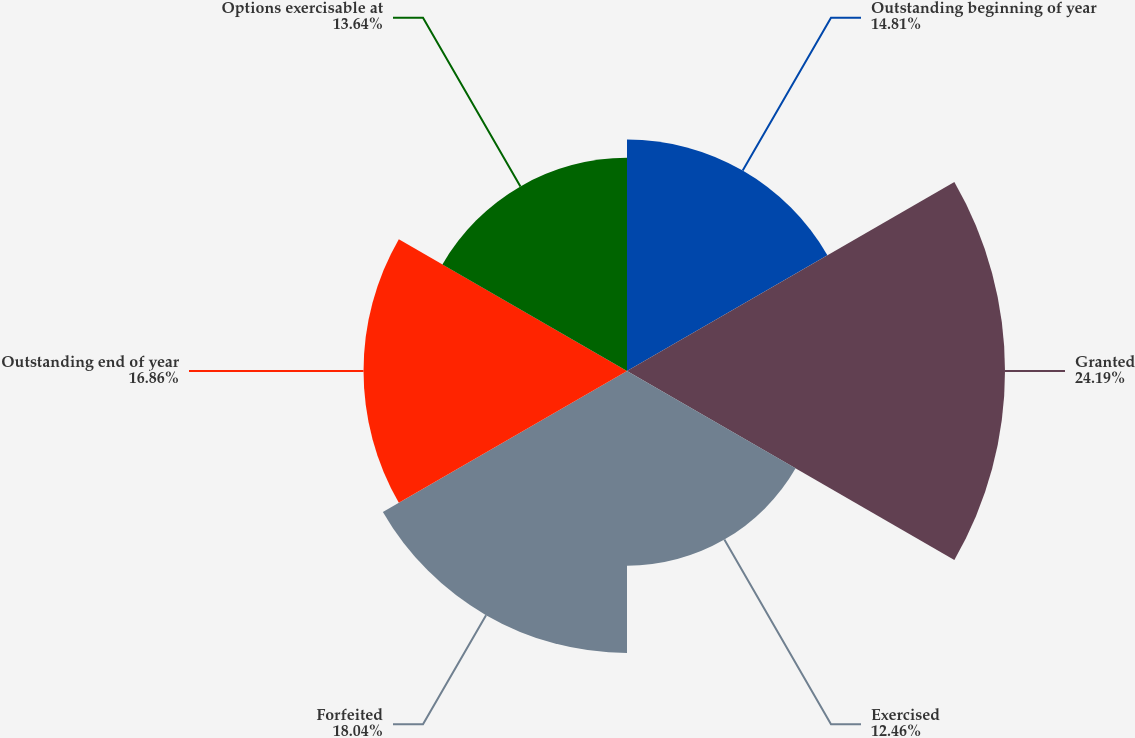Convert chart. <chart><loc_0><loc_0><loc_500><loc_500><pie_chart><fcel>Outstanding beginning of year<fcel>Granted<fcel>Exercised<fcel>Forfeited<fcel>Outstanding end of year<fcel>Options exercisable at<nl><fcel>14.81%<fcel>24.19%<fcel>12.46%<fcel>18.04%<fcel>16.86%<fcel>13.64%<nl></chart> 